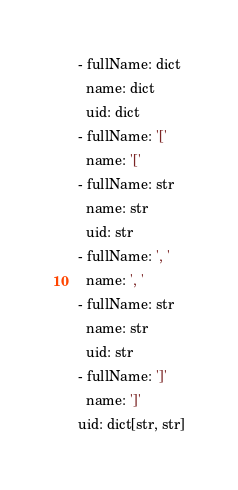<code> <loc_0><loc_0><loc_500><loc_500><_YAML_>  - fullName: dict
    name: dict
    uid: dict
  - fullName: '['
    name: '['
  - fullName: str
    name: str
    uid: str
  - fullName: ', '
    name: ', '
  - fullName: str
    name: str
    uid: str
  - fullName: ']'
    name: ']'
  uid: dict[str, str]
</code> 